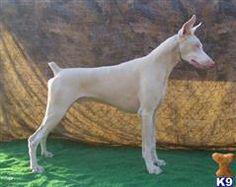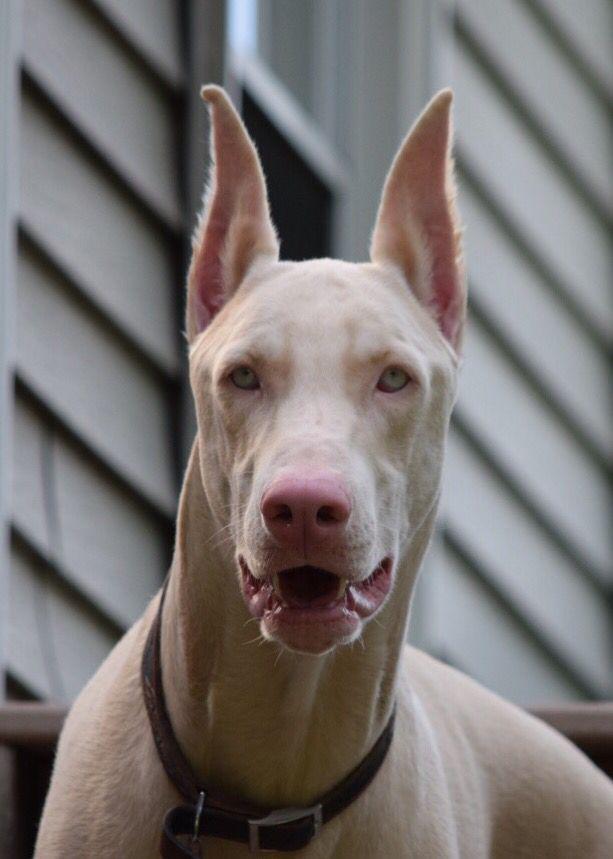The first image is the image on the left, the second image is the image on the right. Given the left and right images, does the statement "There are two dogs with the tips of their ears pointed up" hold true? Answer yes or no. Yes. The first image is the image on the left, the second image is the image on the right. Analyze the images presented: Is the assertion "The ears of the dog in one of the images are down." valid? Answer yes or no. No. 